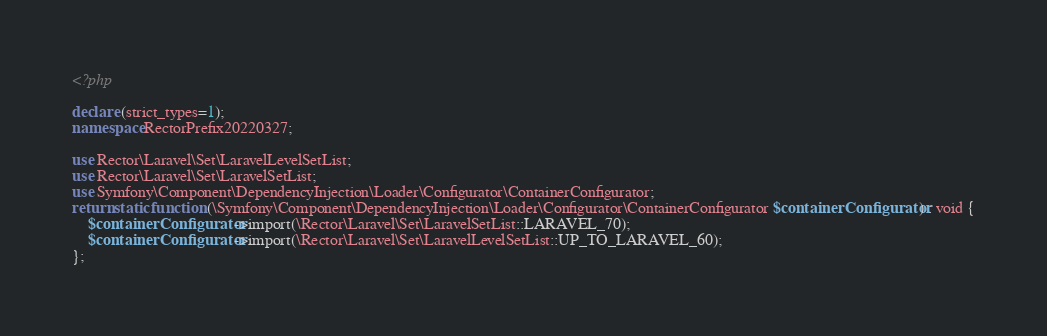<code> <loc_0><loc_0><loc_500><loc_500><_PHP_><?php

declare (strict_types=1);
namespace RectorPrefix20220327;

use Rector\Laravel\Set\LaravelLevelSetList;
use Rector\Laravel\Set\LaravelSetList;
use Symfony\Component\DependencyInjection\Loader\Configurator\ContainerConfigurator;
return static function (\Symfony\Component\DependencyInjection\Loader\Configurator\ContainerConfigurator $containerConfigurator) : void {
    $containerConfigurator->import(\Rector\Laravel\Set\LaravelSetList::LARAVEL_70);
    $containerConfigurator->import(\Rector\Laravel\Set\LaravelLevelSetList::UP_TO_LARAVEL_60);
};
</code> 